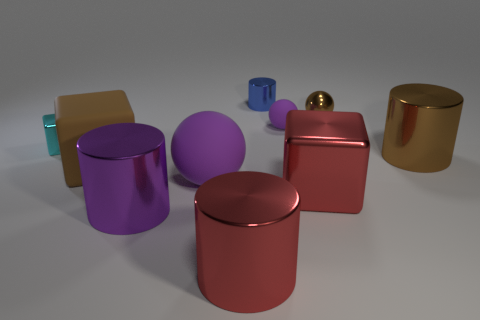What color is the shiny sphere that is the same size as the cyan metal block?
Give a very brief answer. Brown. Is the number of brown metal cylinders to the left of the small matte object greater than the number of big blue metallic balls?
Offer a terse response. No. What is the material of the large thing that is both right of the red cylinder and in front of the brown rubber cube?
Make the answer very short. Metal. There is a cube that is to the right of the purple metallic thing; does it have the same color as the thing behind the small brown thing?
Make the answer very short. No. How many other objects are the same size as the purple cylinder?
Provide a short and direct response. 5. Are there the same number of blue metallic cylinders and small red blocks?
Ensure brevity in your answer.  No. Are there any tiny matte spheres in front of the big metal cylinder right of the matte ball that is behind the brown block?
Make the answer very short. No. Do the purple sphere in front of the big brown cylinder and the tiny purple thing have the same material?
Provide a short and direct response. Yes. There is another tiny thing that is the same shape as the small purple thing; what is its color?
Keep it short and to the point. Brown. Are there any other things that are the same shape as the cyan thing?
Provide a short and direct response. Yes. 